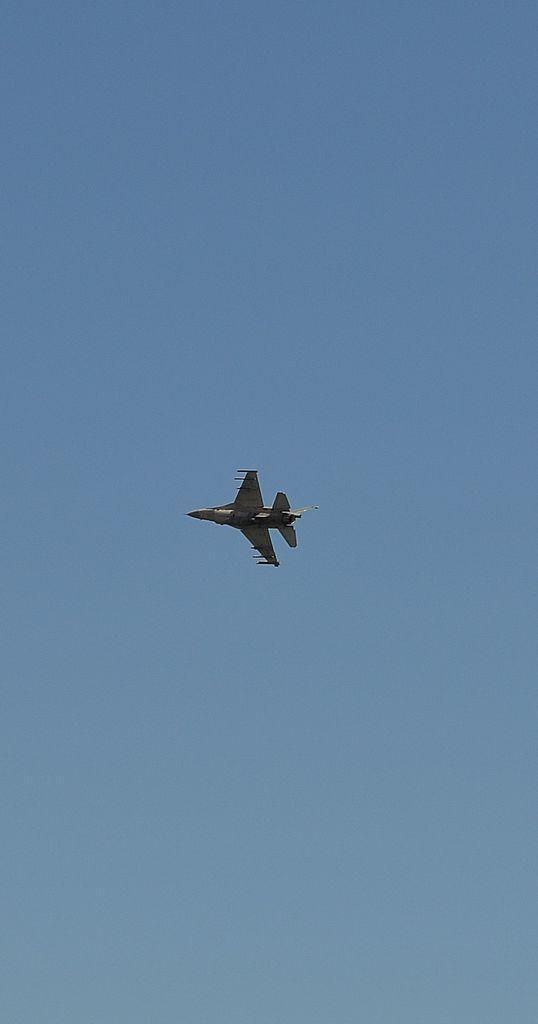Describe this image in one or two sentences. In this picture we can see an airplane in the air. In the background of the image we can see the sky in blue color. 